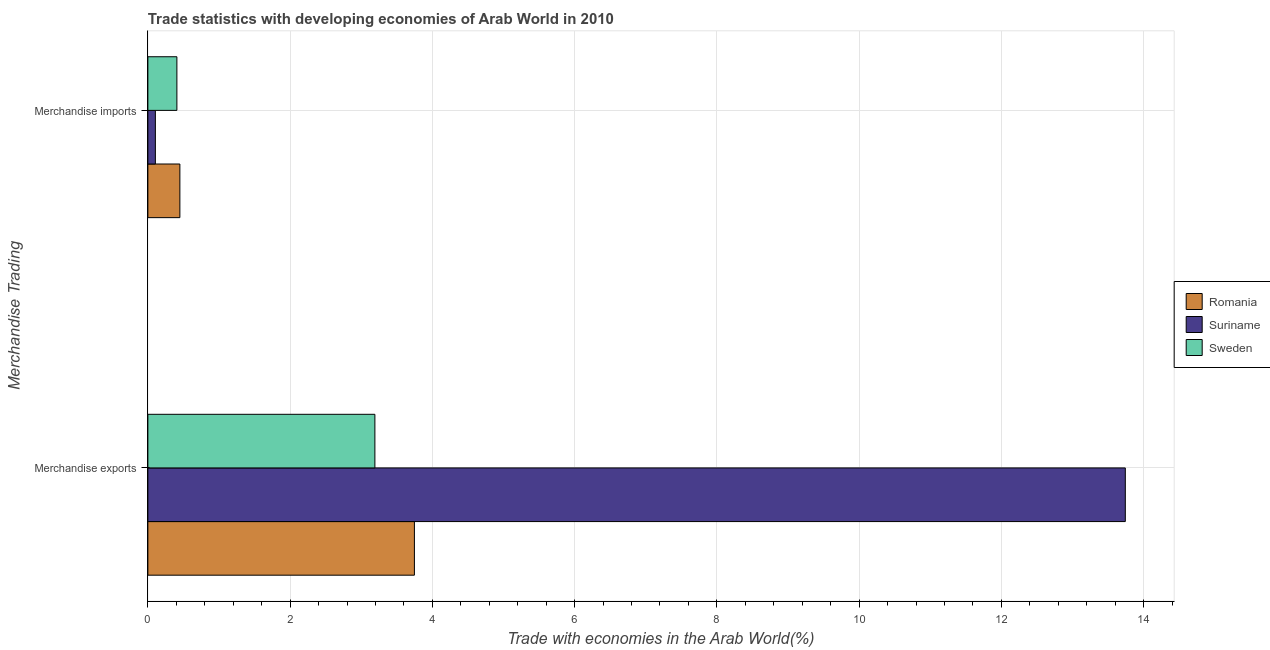How many different coloured bars are there?
Offer a terse response. 3. How many bars are there on the 2nd tick from the top?
Your response must be concise. 3. What is the label of the 2nd group of bars from the top?
Ensure brevity in your answer.  Merchandise exports. What is the merchandise exports in Suriname?
Your answer should be very brief. 13.74. Across all countries, what is the maximum merchandise exports?
Give a very brief answer. 13.74. Across all countries, what is the minimum merchandise imports?
Ensure brevity in your answer.  0.11. In which country was the merchandise imports maximum?
Offer a very short reply. Romania. What is the total merchandise exports in the graph?
Keep it short and to the point. 20.68. What is the difference between the merchandise exports in Suriname and that in Sweden?
Give a very brief answer. 10.55. What is the difference between the merchandise imports in Romania and the merchandise exports in Sweden?
Offer a very short reply. -2.74. What is the average merchandise exports per country?
Offer a very short reply. 6.89. What is the difference between the merchandise imports and merchandise exports in Suriname?
Offer a terse response. -13.64. What is the ratio of the merchandise imports in Romania to that in Suriname?
Make the answer very short. 4.27. Is the merchandise imports in Romania less than that in Suriname?
Make the answer very short. No. What does the 3rd bar from the top in Merchandise imports represents?
Your answer should be very brief. Romania. Are all the bars in the graph horizontal?
Keep it short and to the point. Yes. How many countries are there in the graph?
Offer a terse response. 3. Does the graph contain any zero values?
Provide a succinct answer. No. Where does the legend appear in the graph?
Your response must be concise. Center right. How are the legend labels stacked?
Provide a succinct answer. Vertical. What is the title of the graph?
Make the answer very short. Trade statistics with developing economies of Arab World in 2010. What is the label or title of the X-axis?
Keep it short and to the point. Trade with economies in the Arab World(%). What is the label or title of the Y-axis?
Make the answer very short. Merchandise Trading. What is the Trade with economies in the Arab World(%) in Romania in Merchandise exports?
Provide a succinct answer. 3.75. What is the Trade with economies in the Arab World(%) of Suriname in Merchandise exports?
Provide a short and direct response. 13.74. What is the Trade with economies in the Arab World(%) in Sweden in Merchandise exports?
Your answer should be very brief. 3.19. What is the Trade with economies in the Arab World(%) in Romania in Merchandise imports?
Your response must be concise. 0.45. What is the Trade with economies in the Arab World(%) of Suriname in Merchandise imports?
Keep it short and to the point. 0.11. What is the Trade with economies in the Arab World(%) in Sweden in Merchandise imports?
Your answer should be very brief. 0.41. Across all Merchandise Trading, what is the maximum Trade with economies in the Arab World(%) of Romania?
Offer a terse response. 3.75. Across all Merchandise Trading, what is the maximum Trade with economies in the Arab World(%) in Suriname?
Offer a very short reply. 13.74. Across all Merchandise Trading, what is the maximum Trade with economies in the Arab World(%) of Sweden?
Provide a succinct answer. 3.19. Across all Merchandise Trading, what is the minimum Trade with economies in the Arab World(%) in Romania?
Offer a terse response. 0.45. Across all Merchandise Trading, what is the minimum Trade with economies in the Arab World(%) in Suriname?
Offer a terse response. 0.11. Across all Merchandise Trading, what is the minimum Trade with economies in the Arab World(%) of Sweden?
Your answer should be very brief. 0.41. What is the total Trade with economies in the Arab World(%) of Romania in the graph?
Make the answer very short. 4.2. What is the total Trade with economies in the Arab World(%) in Suriname in the graph?
Provide a succinct answer. 13.85. What is the total Trade with economies in the Arab World(%) of Sweden in the graph?
Offer a very short reply. 3.6. What is the difference between the Trade with economies in the Arab World(%) of Romania in Merchandise exports and that in Merchandise imports?
Provide a short and direct response. 3.3. What is the difference between the Trade with economies in the Arab World(%) in Suriname in Merchandise exports and that in Merchandise imports?
Provide a succinct answer. 13.64. What is the difference between the Trade with economies in the Arab World(%) in Sweden in Merchandise exports and that in Merchandise imports?
Give a very brief answer. 2.78. What is the difference between the Trade with economies in the Arab World(%) of Romania in Merchandise exports and the Trade with economies in the Arab World(%) of Suriname in Merchandise imports?
Offer a very short reply. 3.64. What is the difference between the Trade with economies in the Arab World(%) in Romania in Merchandise exports and the Trade with economies in the Arab World(%) in Sweden in Merchandise imports?
Your answer should be compact. 3.34. What is the difference between the Trade with economies in the Arab World(%) of Suriname in Merchandise exports and the Trade with economies in the Arab World(%) of Sweden in Merchandise imports?
Make the answer very short. 13.33. What is the average Trade with economies in the Arab World(%) of Romania per Merchandise Trading?
Your answer should be compact. 2.1. What is the average Trade with economies in the Arab World(%) of Suriname per Merchandise Trading?
Your answer should be compact. 6.92. What is the average Trade with economies in the Arab World(%) in Sweden per Merchandise Trading?
Make the answer very short. 1.8. What is the difference between the Trade with economies in the Arab World(%) of Romania and Trade with economies in the Arab World(%) of Suriname in Merchandise exports?
Give a very brief answer. -9.99. What is the difference between the Trade with economies in the Arab World(%) of Romania and Trade with economies in the Arab World(%) of Sweden in Merchandise exports?
Provide a short and direct response. 0.56. What is the difference between the Trade with economies in the Arab World(%) in Suriname and Trade with economies in the Arab World(%) in Sweden in Merchandise exports?
Your answer should be compact. 10.55. What is the difference between the Trade with economies in the Arab World(%) of Romania and Trade with economies in the Arab World(%) of Suriname in Merchandise imports?
Your answer should be very brief. 0.34. What is the difference between the Trade with economies in the Arab World(%) in Romania and Trade with economies in the Arab World(%) in Sweden in Merchandise imports?
Provide a succinct answer. 0.04. What is the difference between the Trade with economies in the Arab World(%) of Suriname and Trade with economies in the Arab World(%) of Sweden in Merchandise imports?
Offer a very short reply. -0.3. What is the ratio of the Trade with economies in the Arab World(%) in Romania in Merchandise exports to that in Merchandise imports?
Ensure brevity in your answer.  8.33. What is the ratio of the Trade with economies in the Arab World(%) in Suriname in Merchandise exports to that in Merchandise imports?
Offer a terse response. 130.26. What is the ratio of the Trade with economies in the Arab World(%) in Sweden in Merchandise exports to that in Merchandise imports?
Make the answer very short. 7.82. What is the difference between the highest and the second highest Trade with economies in the Arab World(%) of Romania?
Provide a short and direct response. 3.3. What is the difference between the highest and the second highest Trade with economies in the Arab World(%) of Suriname?
Your response must be concise. 13.64. What is the difference between the highest and the second highest Trade with economies in the Arab World(%) in Sweden?
Offer a very short reply. 2.78. What is the difference between the highest and the lowest Trade with economies in the Arab World(%) of Romania?
Your response must be concise. 3.3. What is the difference between the highest and the lowest Trade with economies in the Arab World(%) in Suriname?
Provide a short and direct response. 13.64. What is the difference between the highest and the lowest Trade with economies in the Arab World(%) of Sweden?
Keep it short and to the point. 2.78. 